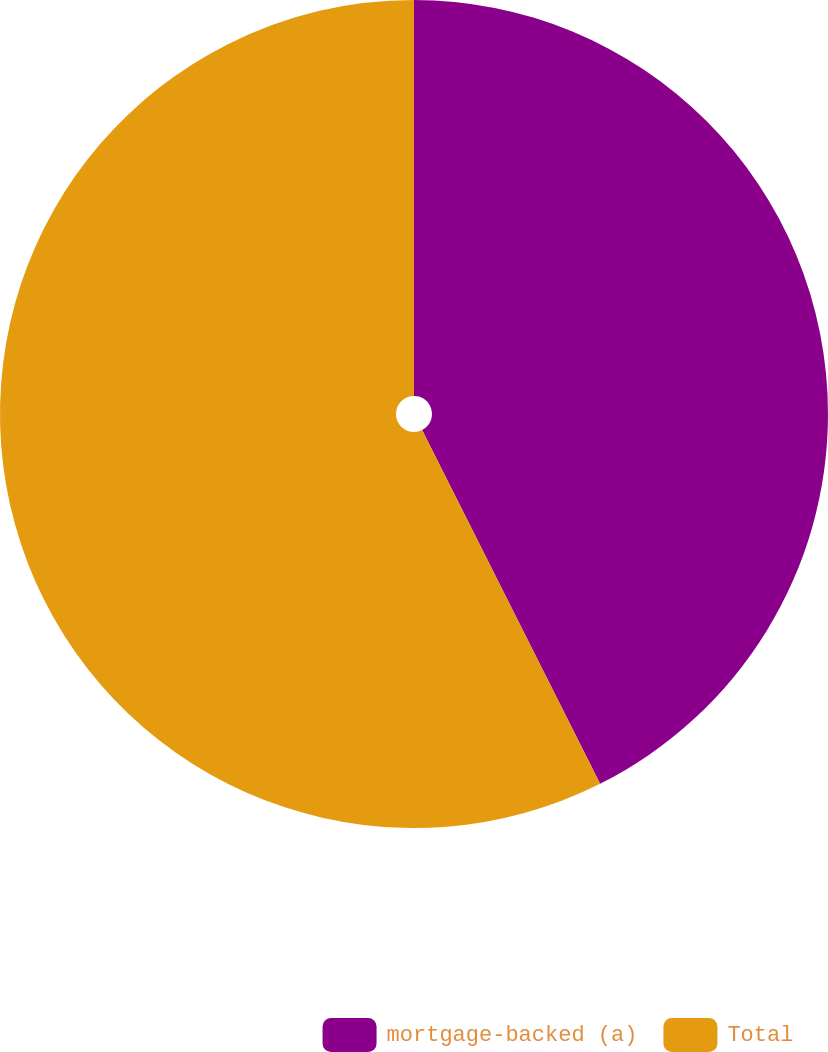Convert chart. <chart><loc_0><loc_0><loc_500><loc_500><pie_chart><fcel>mortgage-backed (a)<fcel>Total<nl><fcel>42.58%<fcel>57.42%<nl></chart> 